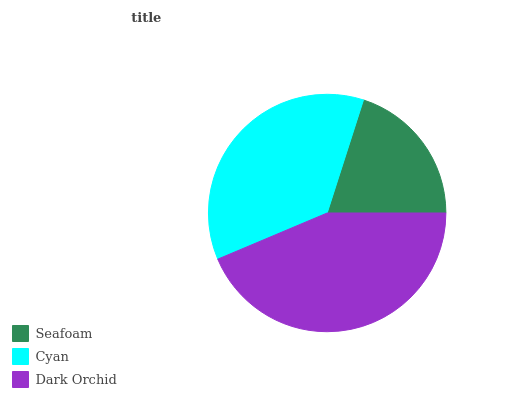Is Seafoam the minimum?
Answer yes or no. Yes. Is Dark Orchid the maximum?
Answer yes or no. Yes. Is Cyan the minimum?
Answer yes or no. No. Is Cyan the maximum?
Answer yes or no. No. Is Cyan greater than Seafoam?
Answer yes or no. Yes. Is Seafoam less than Cyan?
Answer yes or no. Yes. Is Seafoam greater than Cyan?
Answer yes or no. No. Is Cyan less than Seafoam?
Answer yes or no. No. Is Cyan the high median?
Answer yes or no. Yes. Is Cyan the low median?
Answer yes or no. Yes. Is Seafoam the high median?
Answer yes or no. No. Is Dark Orchid the low median?
Answer yes or no. No. 